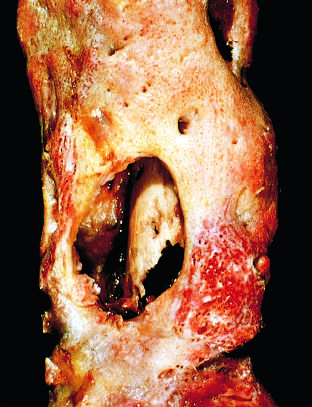does the anterior mitral leaflet show the inner native necrotic cortex (sequestrum)?
Answer the question using a single word or phrase. No 